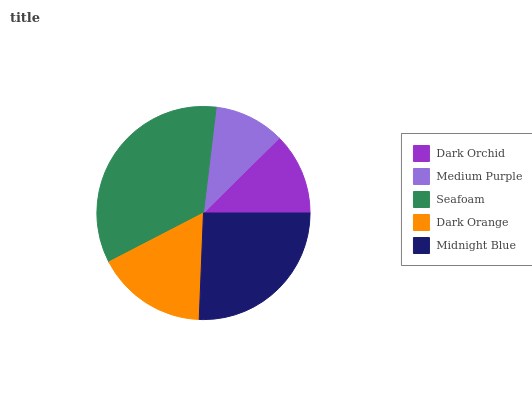Is Medium Purple the minimum?
Answer yes or no. Yes. Is Seafoam the maximum?
Answer yes or no. Yes. Is Seafoam the minimum?
Answer yes or no. No. Is Medium Purple the maximum?
Answer yes or no. No. Is Seafoam greater than Medium Purple?
Answer yes or no. Yes. Is Medium Purple less than Seafoam?
Answer yes or no. Yes. Is Medium Purple greater than Seafoam?
Answer yes or no. No. Is Seafoam less than Medium Purple?
Answer yes or no. No. Is Dark Orange the high median?
Answer yes or no. Yes. Is Dark Orange the low median?
Answer yes or no. Yes. Is Seafoam the high median?
Answer yes or no. No. Is Seafoam the low median?
Answer yes or no. No. 